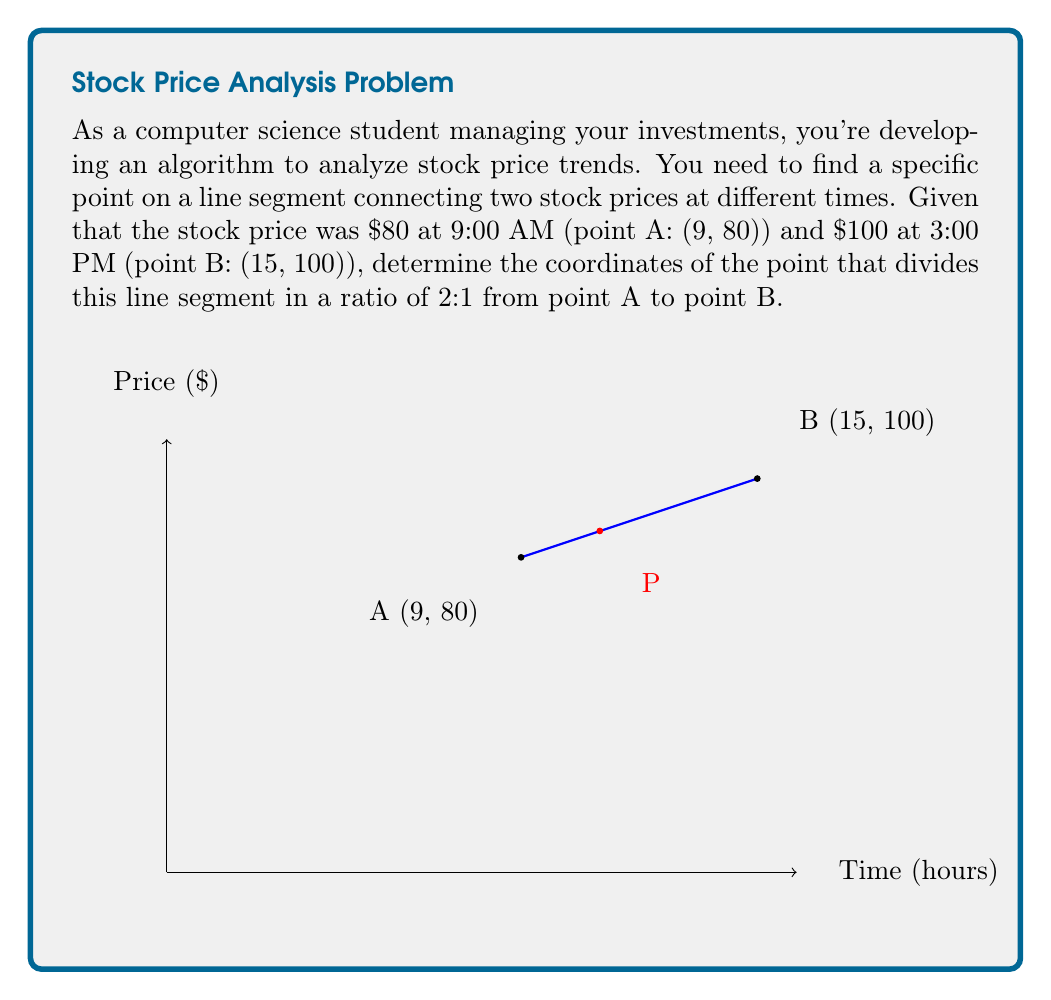Show me your answer to this math problem. To solve this problem, we'll use the section formula for dividing a line segment in a given ratio. The formula states that if a point P divides the line segment AB in the ratio m:n, then its coordinates are given by:

$$P = \left(\frac{mx_2 + nx_1}{m+n}, \frac{my_2 + ny_1}{m+n}\right)$$

Where $(x_1, y_1)$ are the coordinates of point A, and $(x_2, y_2)$ are the coordinates of point B.

Given:
- Point A: (9, 80)
- Point B: (15, 100)
- Ratio: 2:1 (m:n)

Step 1: Identify the values for the formula
$x_1 = 9$, $y_1 = 80$
$x_2 = 15$, $y_2 = 100$
$m = 2$, $n = 1$

Step 2: Calculate the x-coordinate of point P
$$x = \frac{mx_2 + nx_1}{m+n} = \frac{2(15) + 1(9)}{2+1} = \frac{30 + 9}{3} = \frac{39}{3} = 13$$

Step 3: Calculate the y-coordinate of point P
$$y = \frac{my_2 + ny_1}{m+n} = \frac{2(100) + 1(80)}{2+1} = \frac{200 + 80}{3} = \frac{280}{3} = \frac{280}{3}$$

Therefore, the coordinates of point P are (13, 280/3).

Step 4: Interpret the result
The x-coordinate 13 represents 1:00 PM (13:00), and the y-coordinate 280/3 ≈ 93.33 represents the stock price at that time.
Answer: (13, 280/3) 